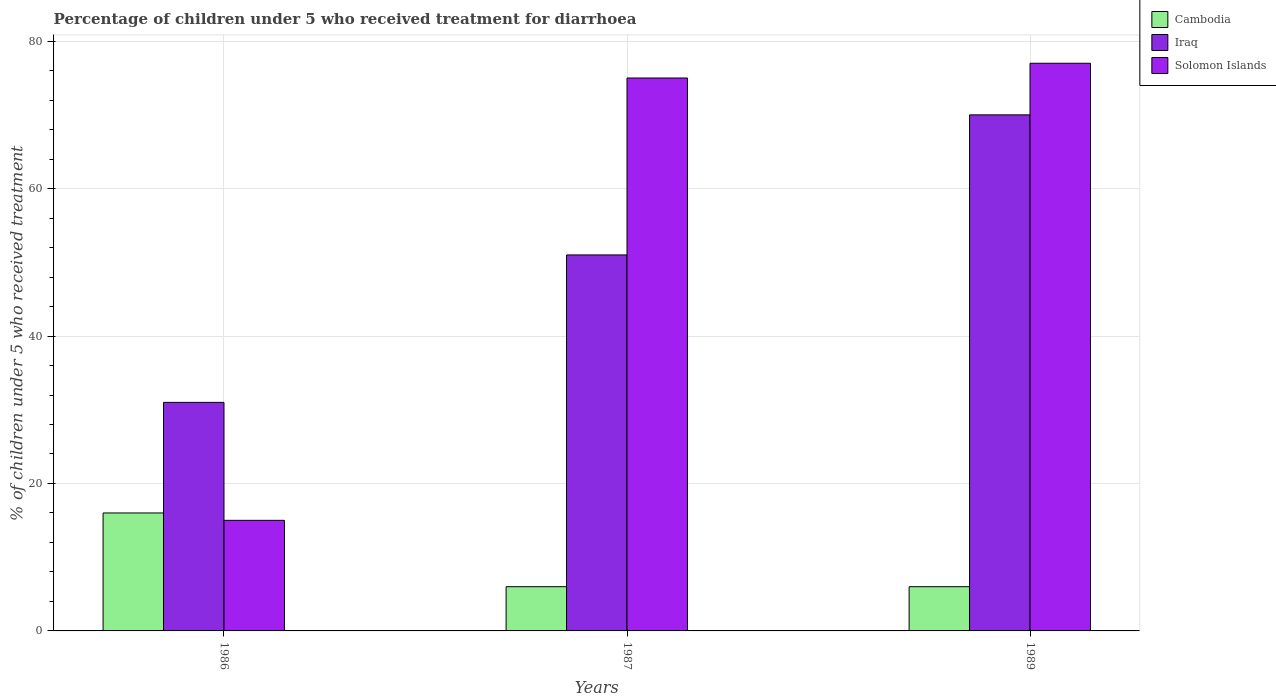Are the number of bars per tick equal to the number of legend labels?
Your answer should be very brief. Yes. How many bars are there on the 1st tick from the left?
Your response must be concise. 3. How many bars are there on the 3rd tick from the right?
Provide a succinct answer. 3. What is the label of the 2nd group of bars from the left?
Provide a succinct answer. 1987. Across all years, what is the maximum percentage of children who received treatment for diarrhoea  in Solomon Islands?
Provide a succinct answer. 77. In which year was the percentage of children who received treatment for diarrhoea  in Iraq maximum?
Provide a short and direct response. 1989. In which year was the percentage of children who received treatment for diarrhoea  in Cambodia minimum?
Provide a short and direct response. 1987. What is the total percentage of children who received treatment for diarrhoea  in Cambodia in the graph?
Your response must be concise. 28. What is the difference between the percentage of children who received treatment for diarrhoea  in Cambodia in 1986 and that in 1989?
Provide a succinct answer. 10. What is the average percentage of children who received treatment for diarrhoea  in Iraq per year?
Provide a short and direct response. 50.67. In the year 1989, what is the difference between the percentage of children who received treatment for diarrhoea  in Cambodia and percentage of children who received treatment for diarrhoea  in Iraq?
Your response must be concise. -64. What is the ratio of the percentage of children who received treatment for diarrhoea  in Iraq in 1987 to that in 1989?
Offer a terse response. 0.73. Is the difference between the percentage of children who received treatment for diarrhoea  in Cambodia in 1986 and 1987 greater than the difference between the percentage of children who received treatment for diarrhoea  in Iraq in 1986 and 1987?
Keep it short and to the point. Yes. In how many years, is the percentage of children who received treatment for diarrhoea  in Solomon Islands greater than the average percentage of children who received treatment for diarrhoea  in Solomon Islands taken over all years?
Keep it short and to the point. 2. What does the 3rd bar from the left in 1986 represents?
Keep it short and to the point. Solomon Islands. What does the 1st bar from the right in 1989 represents?
Offer a very short reply. Solomon Islands. Are the values on the major ticks of Y-axis written in scientific E-notation?
Offer a terse response. No. Does the graph contain grids?
Your response must be concise. Yes. Where does the legend appear in the graph?
Give a very brief answer. Top right. How are the legend labels stacked?
Your answer should be compact. Vertical. What is the title of the graph?
Offer a terse response. Percentage of children under 5 who received treatment for diarrhoea. What is the label or title of the X-axis?
Keep it short and to the point. Years. What is the label or title of the Y-axis?
Offer a terse response. % of children under 5 who received treatment. What is the % of children under 5 who received treatment in Cambodia in 1986?
Keep it short and to the point. 16. What is the % of children under 5 who received treatment in Iraq in 1986?
Offer a terse response. 31. What is the % of children under 5 who received treatment in Cambodia in 1987?
Make the answer very short. 6. What is the % of children under 5 who received treatment of Cambodia in 1989?
Offer a very short reply. 6. What is the % of children under 5 who received treatment in Solomon Islands in 1989?
Make the answer very short. 77. Across all years, what is the maximum % of children under 5 who received treatment in Cambodia?
Your answer should be compact. 16. Across all years, what is the minimum % of children under 5 who received treatment of Cambodia?
Offer a terse response. 6. Across all years, what is the minimum % of children under 5 who received treatment of Solomon Islands?
Your answer should be compact. 15. What is the total % of children under 5 who received treatment in Iraq in the graph?
Your answer should be very brief. 152. What is the total % of children under 5 who received treatment of Solomon Islands in the graph?
Your answer should be compact. 167. What is the difference between the % of children under 5 who received treatment of Cambodia in 1986 and that in 1987?
Your answer should be compact. 10. What is the difference between the % of children under 5 who received treatment of Solomon Islands in 1986 and that in 1987?
Give a very brief answer. -60. What is the difference between the % of children under 5 who received treatment in Cambodia in 1986 and that in 1989?
Give a very brief answer. 10. What is the difference between the % of children under 5 who received treatment in Iraq in 1986 and that in 1989?
Keep it short and to the point. -39. What is the difference between the % of children under 5 who received treatment in Solomon Islands in 1986 and that in 1989?
Provide a short and direct response. -62. What is the difference between the % of children under 5 who received treatment of Solomon Islands in 1987 and that in 1989?
Give a very brief answer. -2. What is the difference between the % of children under 5 who received treatment in Cambodia in 1986 and the % of children under 5 who received treatment in Iraq in 1987?
Ensure brevity in your answer.  -35. What is the difference between the % of children under 5 who received treatment in Cambodia in 1986 and the % of children under 5 who received treatment in Solomon Islands in 1987?
Provide a succinct answer. -59. What is the difference between the % of children under 5 who received treatment in Iraq in 1986 and the % of children under 5 who received treatment in Solomon Islands in 1987?
Your response must be concise. -44. What is the difference between the % of children under 5 who received treatment of Cambodia in 1986 and the % of children under 5 who received treatment of Iraq in 1989?
Your answer should be compact. -54. What is the difference between the % of children under 5 who received treatment of Cambodia in 1986 and the % of children under 5 who received treatment of Solomon Islands in 1989?
Your answer should be very brief. -61. What is the difference between the % of children under 5 who received treatment of Iraq in 1986 and the % of children under 5 who received treatment of Solomon Islands in 1989?
Offer a terse response. -46. What is the difference between the % of children under 5 who received treatment in Cambodia in 1987 and the % of children under 5 who received treatment in Iraq in 1989?
Provide a succinct answer. -64. What is the difference between the % of children under 5 who received treatment in Cambodia in 1987 and the % of children under 5 who received treatment in Solomon Islands in 1989?
Keep it short and to the point. -71. What is the average % of children under 5 who received treatment of Cambodia per year?
Your response must be concise. 9.33. What is the average % of children under 5 who received treatment of Iraq per year?
Make the answer very short. 50.67. What is the average % of children under 5 who received treatment in Solomon Islands per year?
Your answer should be compact. 55.67. In the year 1986, what is the difference between the % of children under 5 who received treatment of Cambodia and % of children under 5 who received treatment of Iraq?
Give a very brief answer. -15. In the year 1986, what is the difference between the % of children under 5 who received treatment of Iraq and % of children under 5 who received treatment of Solomon Islands?
Give a very brief answer. 16. In the year 1987, what is the difference between the % of children under 5 who received treatment of Cambodia and % of children under 5 who received treatment of Iraq?
Provide a succinct answer. -45. In the year 1987, what is the difference between the % of children under 5 who received treatment of Cambodia and % of children under 5 who received treatment of Solomon Islands?
Provide a short and direct response. -69. In the year 1989, what is the difference between the % of children under 5 who received treatment in Cambodia and % of children under 5 who received treatment in Iraq?
Ensure brevity in your answer.  -64. In the year 1989, what is the difference between the % of children under 5 who received treatment of Cambodia and % of children under 5 who received treatment of Solomon Islands?
Provide a short and direct response. -71. In the year 1989, what is the difference between the % of children under 5 who received treatment of Iraq and % of children under 5 who received treatment of Solomon Islands?
Your answer should be very brief. -7. What is the ratio of the % of children under 5 who received treatment in Cambodia in 1986 to that in 1987?
Ensure brevity in your answer.  2.67. What is the ratio of the % of children under 5 who received treatment of Iraq in 1986 to that in 1987?
Offer a very short reply. 0.61. What is the ratio of the % of children under 5 who received treatment in Solomon Islands in 1986 to that in 1987?
Keep it short and to the point. 0.2. What is the ratio of the % of children under 5 who received treatment in Cambodia in 1986 to that in 1989?
Your response must be concise. 2.67. What is the ratio of the % of children under 5 who received treatment of Iraq in 1986 to that in 1989?
Provide a succinct answer. 0.44. What is the ratio of the % of children under 5 who received treatment in Solomon Islands in 1986 to that in 1989?
Your answer should be very brief. 0.19. What is the ratio of the % of children under 5 who received treatment of Cambodia in 1987 to that in 1989?
Your answer should be compact. 1. What is the ratio of the % of children under 5 who received treatment in Iraq in 1987 to that in 1989?
Provide a succinct answer. 0.73. What is the difference between the highest and the lowest % of children under 5 who received treatment of Cambodia?
Your answer should be compact. 10. What is the difference between the highest and the lowest % of children under 5 who received treatment in Solomon Islands?
Offer a very short reply. 62. 